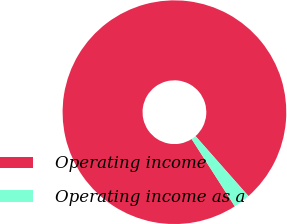Convert chart to OTSL. <chart><loc_0><loc_0><loc_500><loc_500><pie_chart><fcel>Operating income<fcel>Operating income as a<nl><fcel>97.57%<fcel>2.43%<nl></chart> 